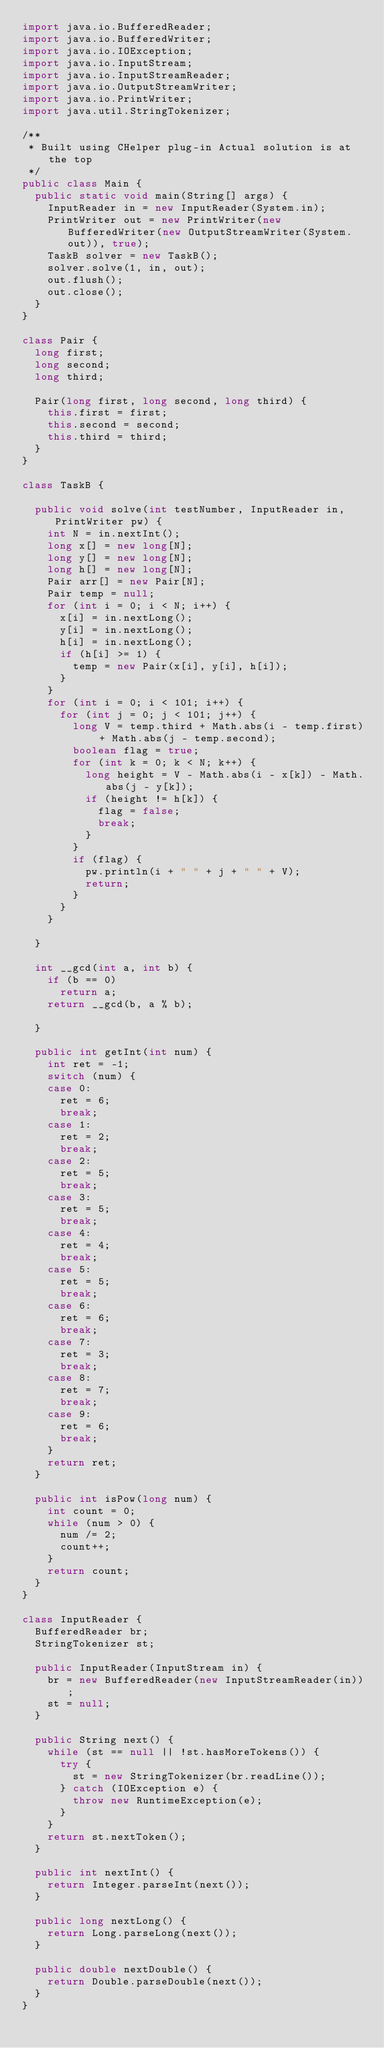<code> <loc_0><loc_0><loc_500><loc_500><_Java_>import java.io.BufferedReader;
import java.io.BufferedWriter;
import java.io.IOException;
import java.io.InputStream;
import java.io.InputStreamReader;
import java.io.OutputStreamWriter;
import java.io.PrintWriter;
import java.util.StringTokenizer;

/**
 * Built using CHelper plug-in Actual solution is at the top
 */
public class Main {
	public static void main(String[] args) {
		InputReader in = new InputReader(System.in);
		PrintWriter out = new PrintWriter(new BufferedWriter(new OutputStreamWriter(System.out)), true);
		TaskB solver = new TaskB();
		solver.solve(1, in, out);
		out.flush();
		out.close();
	}
}

class Pair {
	long first;
	long second;
	long third;

	Pair(long first, long second, long third) {
		this.first = first;
		this.second = second;
		this.third = third;
	}
}

class TaskB {

	public void solve(int testNumber, InputReader in, PrintWriter pw) {
		int N = in.nextInt();
		long x[] = new long[N];
		long y[] = new long[N];
		long h[] = new long[N];
		Pair arr[] = new Pair[N];
		Pair temp = null;
		for (int i = 0; i < N; i++) {
			x[i] = in.nextLong();
			y[i] = in.nextLong();
			h[i] = in.nextLong();
			if (h[i] >= 1) {
				temp = new Pair(x[i], y[i], h[i]);
			}
		}
		for (int i = 0; i < 101; i++) {
			for (int j = 0; j < 101; j++) {
				long V = temp.third + Math.abs(i - temp.first) + Math.abs(j - temp.second);
				boolean flag = true;
				for (int k = 0; k < N; k++) {
					long height = V - Math.abs(i - x[k]) - Math.abs(j - y[k]);
					if (height != h[k]) {
						flag = false;
						break;
					}
				}
				if (flag) {
					pw.println(i + " " + j + " " + V);
					return;
				}
			}
		}

	}

	int __gcd(int a, int b) {
		if (b == 0)
			return a;
		return __gcd(b, a % b);

	}

	public int getInt(int num) {
		int ret = -1;
		switch (num) {
		case 0:
			ret = 6;
			break;
		case 1:
			ret = 2;
			break;
		case 2:
			ret = 5;
			break;
		case 3:
			ret = 5;
			break;
		case 4:
			ret = 4;
			break;
		case 5:
			ret = 5;
			break;
		case 6:
			ret = 6;
			break;
		case 7:
			ret = 3;
			break;
		case 8:
			ret = 7;
			break;
		case 9:
			ret = 6;
			break;
		}
		return ret;
	}

	public int isPow(long num) {
		int count = 0;
		while (num > 0) {
			num /= 2;
			count++;
		}
		return count;
	}
}

class InputReader {
	BufferedReader br;
	StringTokenizer st;

	public InputReader(InputStream in) {
		br = new BufferedReader(new InputStreamReader(in));
		st = null;
	}

	public String next() {
		while (st == null || !st.hasMoreTokens()) {
			try {
				st = new StringTokenizer(br.readLine());
			} catch (IOException e) {
				throw new RuntimeException(e);
			}
		}
		return st.nextToken();
	}

	public int nextInt() {
		return Integer.parseInt(next());
	}

	public long nextLong() {
		return Long.parseLong(next());
	}

	public double nextDouble() {
		return Double.parseDouble(next());
	}
}
</code> 